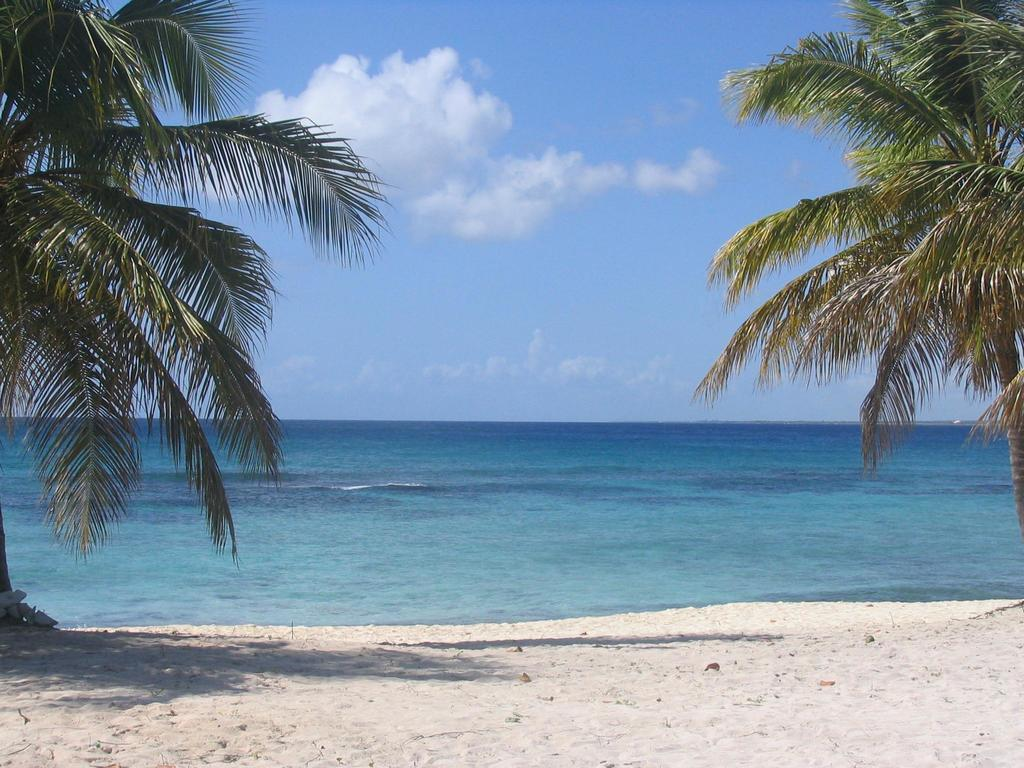What type of vegetation can be seen in the image? There are trees in the image. What natural element is visible in the image besides the trees? There is water visible in the image. What can be seen in the background of the image? The sky is visible in the background of the image. What is the condition of the sky in the image? Clouds are present in the sky. What type of pancake is being prepared by the carpenter in the image? There is no carpenter or pancake present in the image. 